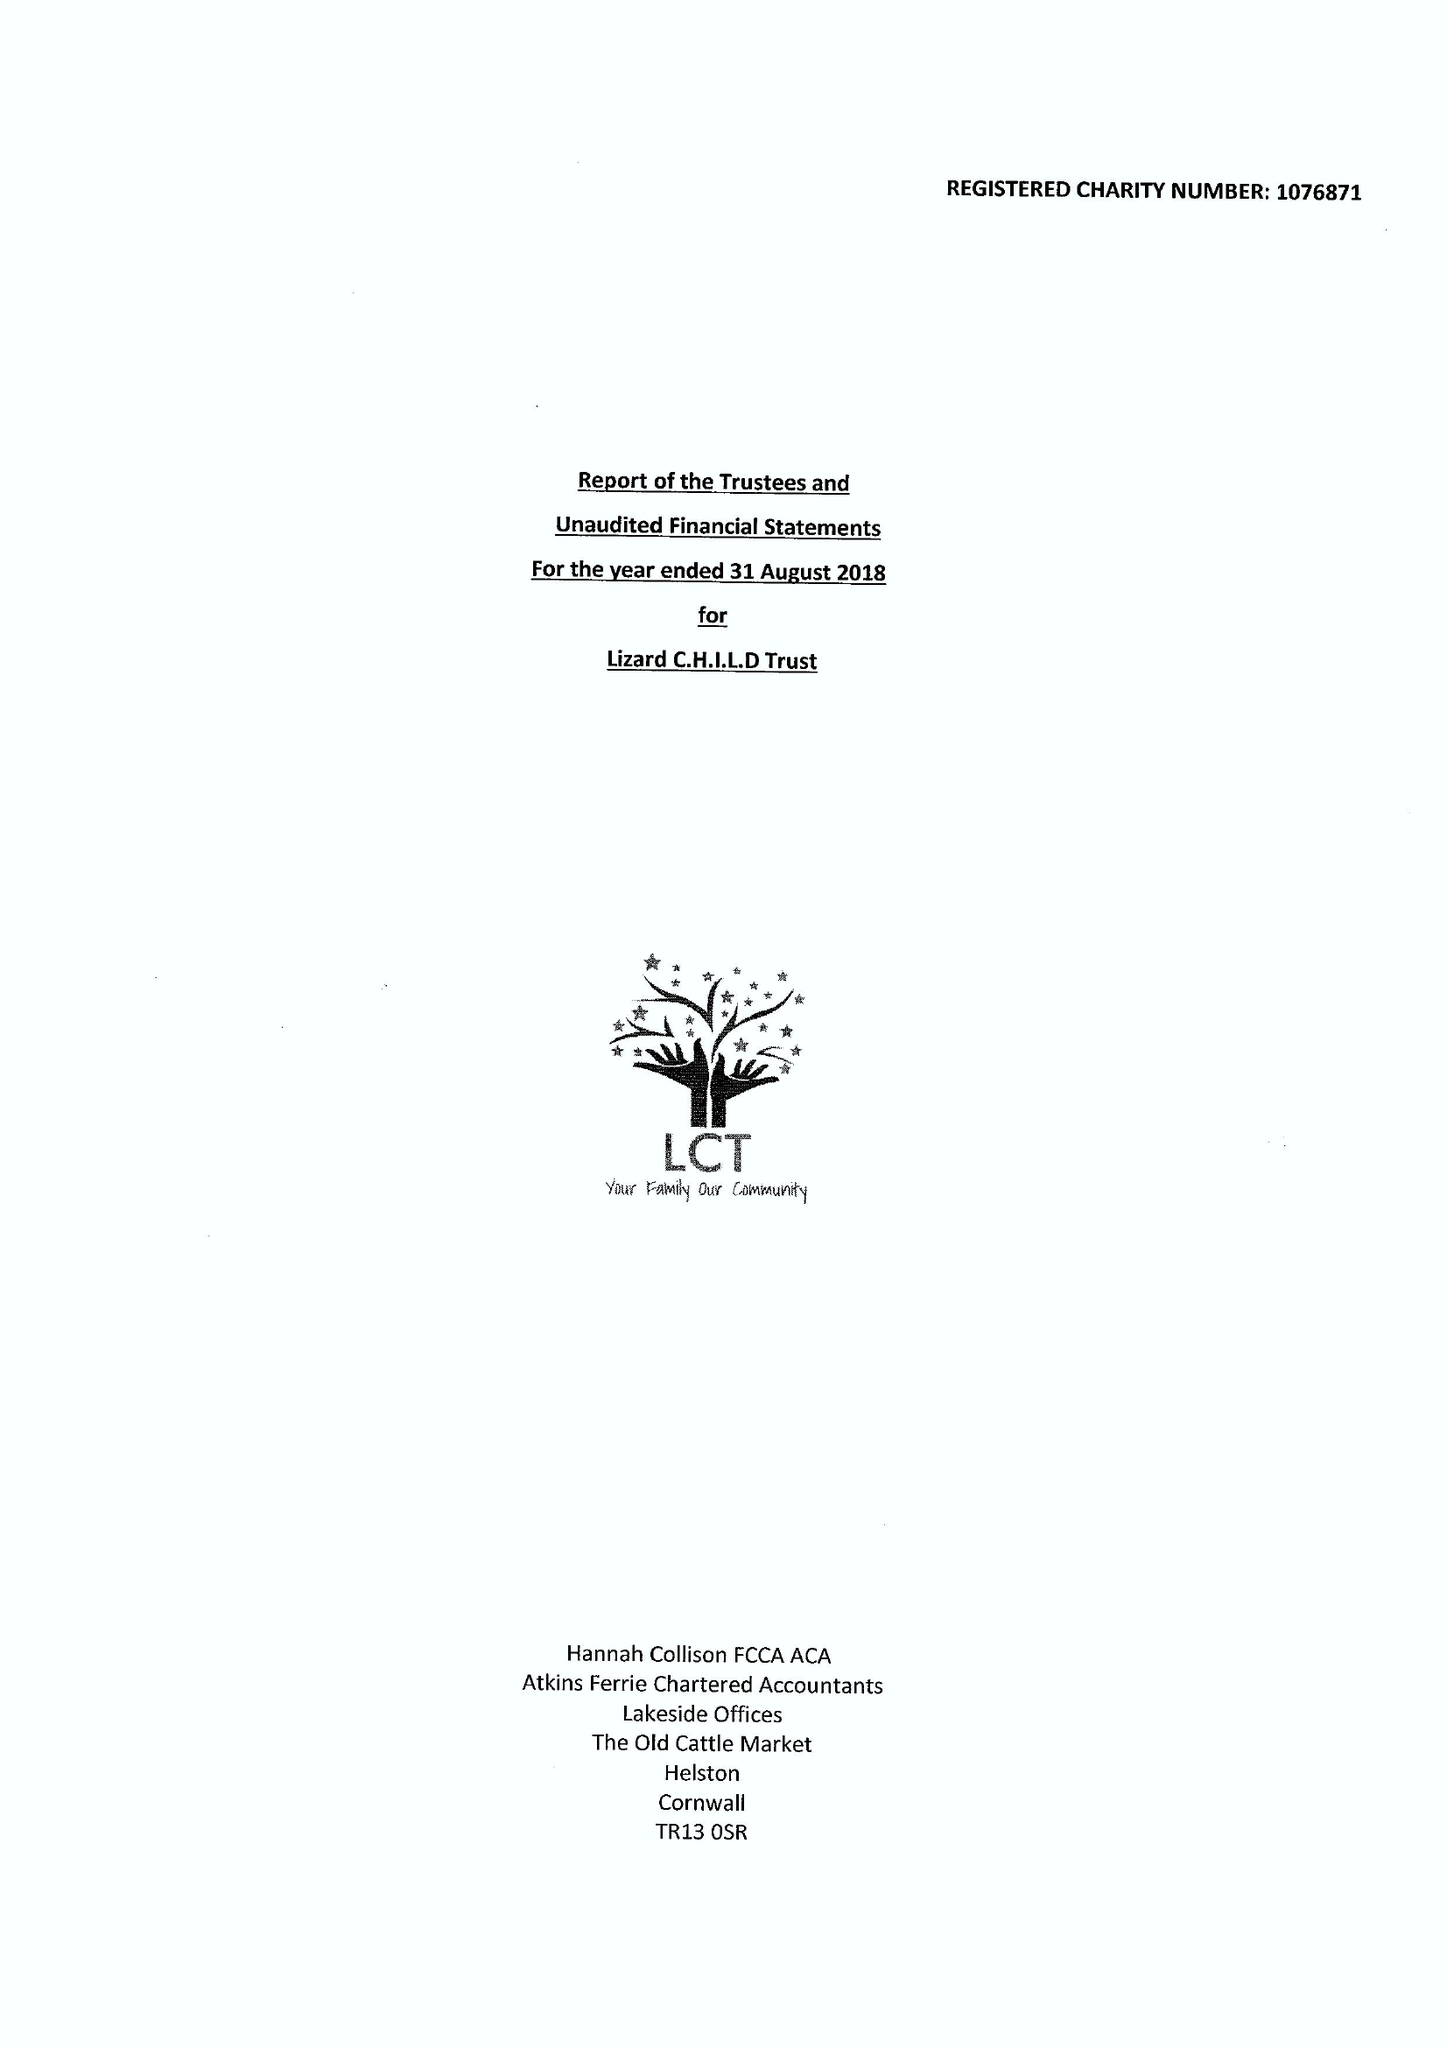What is the value for the report_date?
Answer the question using a single word or phrase. 2018-08-31 